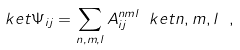Convert formula to latex. <formula><loc_0><loc_0><loc_500><loc_500>\ k e t { \Psi } _ { i j } = \sum _ { n , m , l } A _ { i j } ^ { n m l } \ k e t { n , m , l } \ ,</formula> 